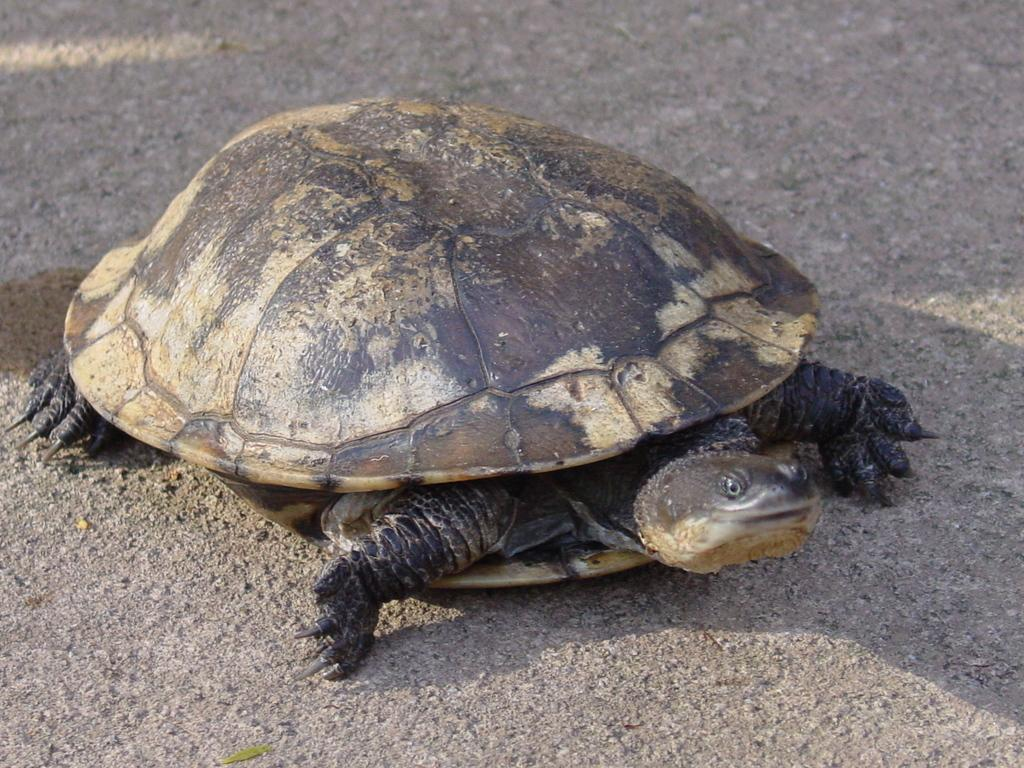What animal is present in the image? There is a tortoise in the image. Where is the tortoise located in the image? The tortoise is on the road in the image. What colors can be seen on the tortoise? The tortoise is in black and cream color. What type of floor can be seen in the image? There is no specific floor visible in the image; it only shows a tortoise on the road. Can you tell me how many attempts the tortoise is making to climb a tree in the image? There is no tree present in the image, and the tortoise is not attempting to climb anything. 